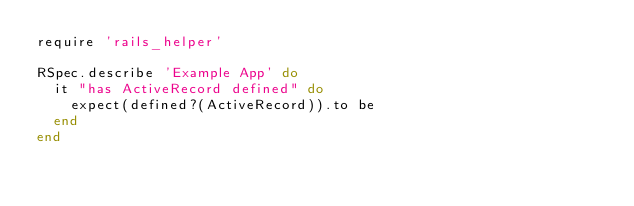<code> <loc_0><loc_0><loc_500><loc_500><_Ruby_>require 'rails_helper'

RSpec.describe 'Example App' do
  it "has ActiveRecord defined" do
    expect(defined?(ActiveRecord)).to be
  end
end
</code> 